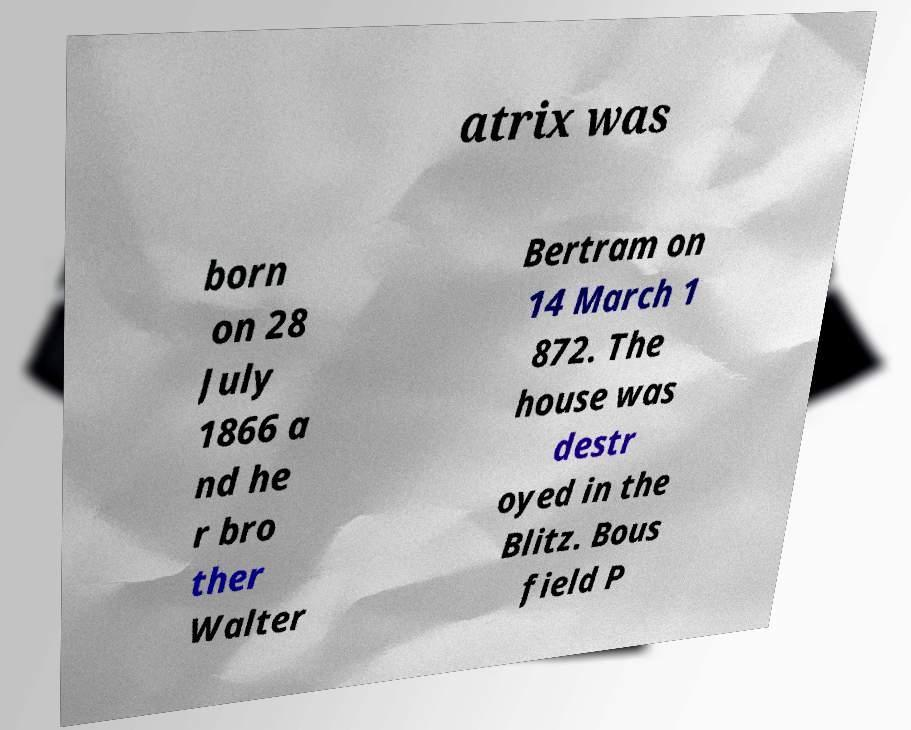Can you accurately transcribe the text from the provided image for me? atrix was born on 28 July 1866 a nd he r bro ther Walter Bertram on 14 March 1 872. The house was destr oyed in the Blitz. Bous field P 